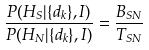<formula> <loc_0><loc_0><loc_500><loc_500>\frac { P ( H _ { S } | \{ d _ { k } \} , I ) } { P ( H _ { N } | \{ d _ { k } \} , I ) } = \frac { B _ { S N } } { T _ { S N } }</formula> 